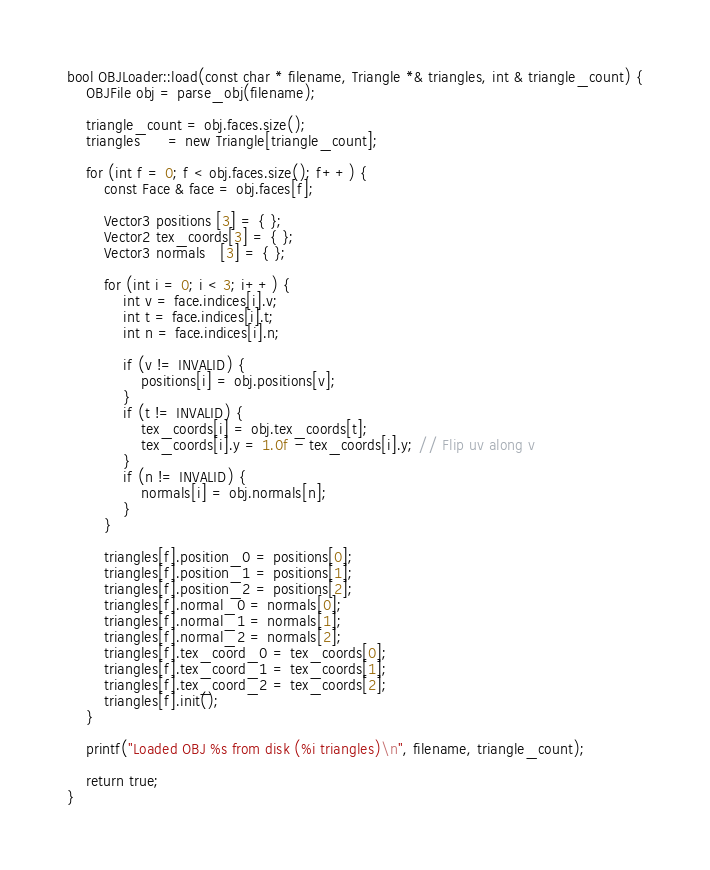Convert code to text. <code><loc_0><loc_0><loc_500><loc_500><_C++_>bool OBJLoader::load(const char * filename, Triangle *& triangles, int & triangle_count) {
	OBJFile obj = parse_obj(filename);

	triangle_count = obj.faces.size();
	triangles      = new Triangle[triangle_count];

	for (int f = 0; f < obj.faces.size(); f++) {
		const Face & face = obj.faces[f];

		Vector3 positions [3] = { };
		Vector2 tex_coords[3] = { };
		Vector3 normals   [3] = { };

		for (int i = 0; i < 3; i++) {
			int v = face.indices[i].v;
			int t = face.indices[i].t;
			int n = face.indices[i].n;

			if (v != INVALID) {
				positions[i] = obj.positions[v];
			}
			if (t != INVALID) {
				tex_coords[i] = obj.tex_coords[t];
				tex_coords[i].y = 1.0f - tex_coords[i].y; // Flip uv along v
			}
			if (n != INVALID) {
				normals[i] = obj.normals[n];
			}
		}

		triangles[f].position_0 = positions[0];
		triangles[f].position_1 = positions[1];
		triangles[f].position_2 = positions[2];
		triangles[f].normal_0 = normals[0];
		triangles[f].normal_1 = normals[1];
		triangles[f].normal_2 = normals[2];
		triangles[f].tex_coord_0 = tex_coords[0];
		triangles[f].tex_coord_1 = tex_coords[1];
		triangles[f].tex_coord_2 = tex_coords[2];
		triangles[f].init();
	}

	printf("Loaded OBJ %s from disk (%i triangles)\n", filename, triangle_count);

	return true;
}
</code> 